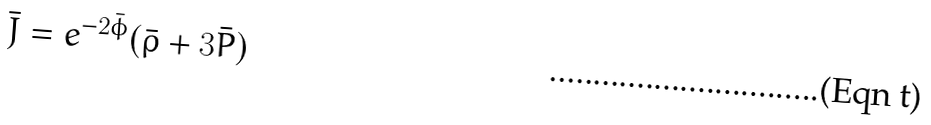Convert formula to latex. <formula><loc_0><loc_0><loc_500><loc_500>\bar { J } = e ^ { - 2 \bar { \phi } } ( \bar { \rho } + 3 \bar { P } )</formula> 